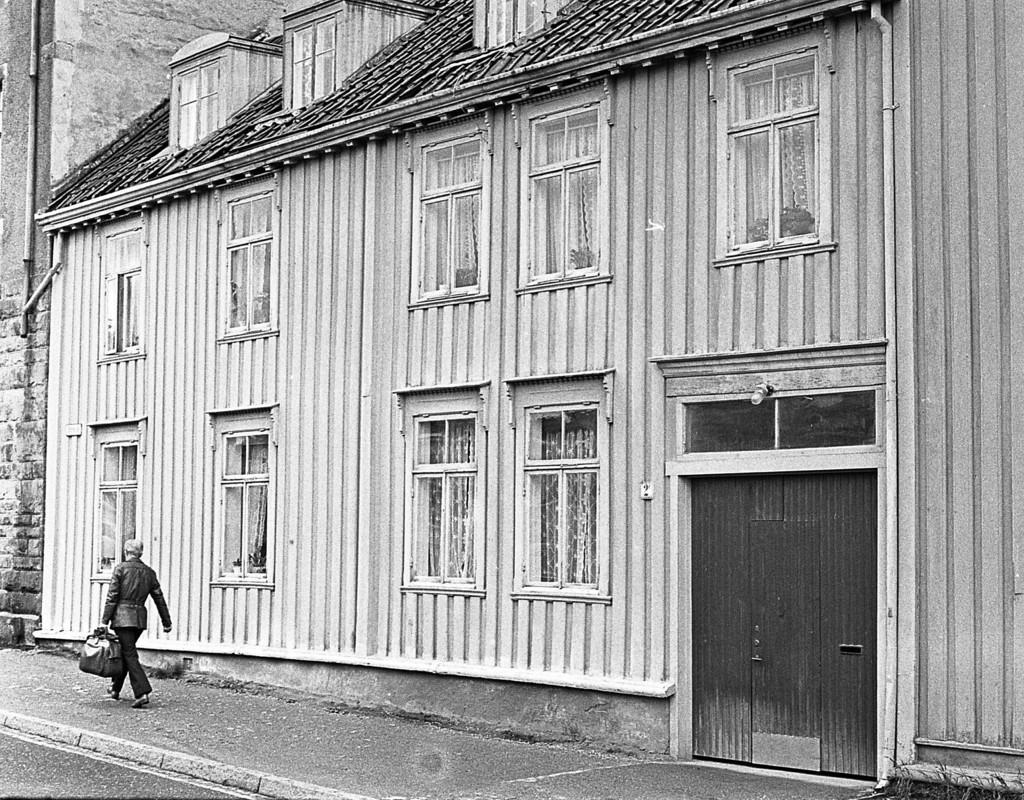Please provide a concise description of this image. This is a black and white picture, in this image we can see the person holding a bag and walking, also we can see a building and there are some windows. 